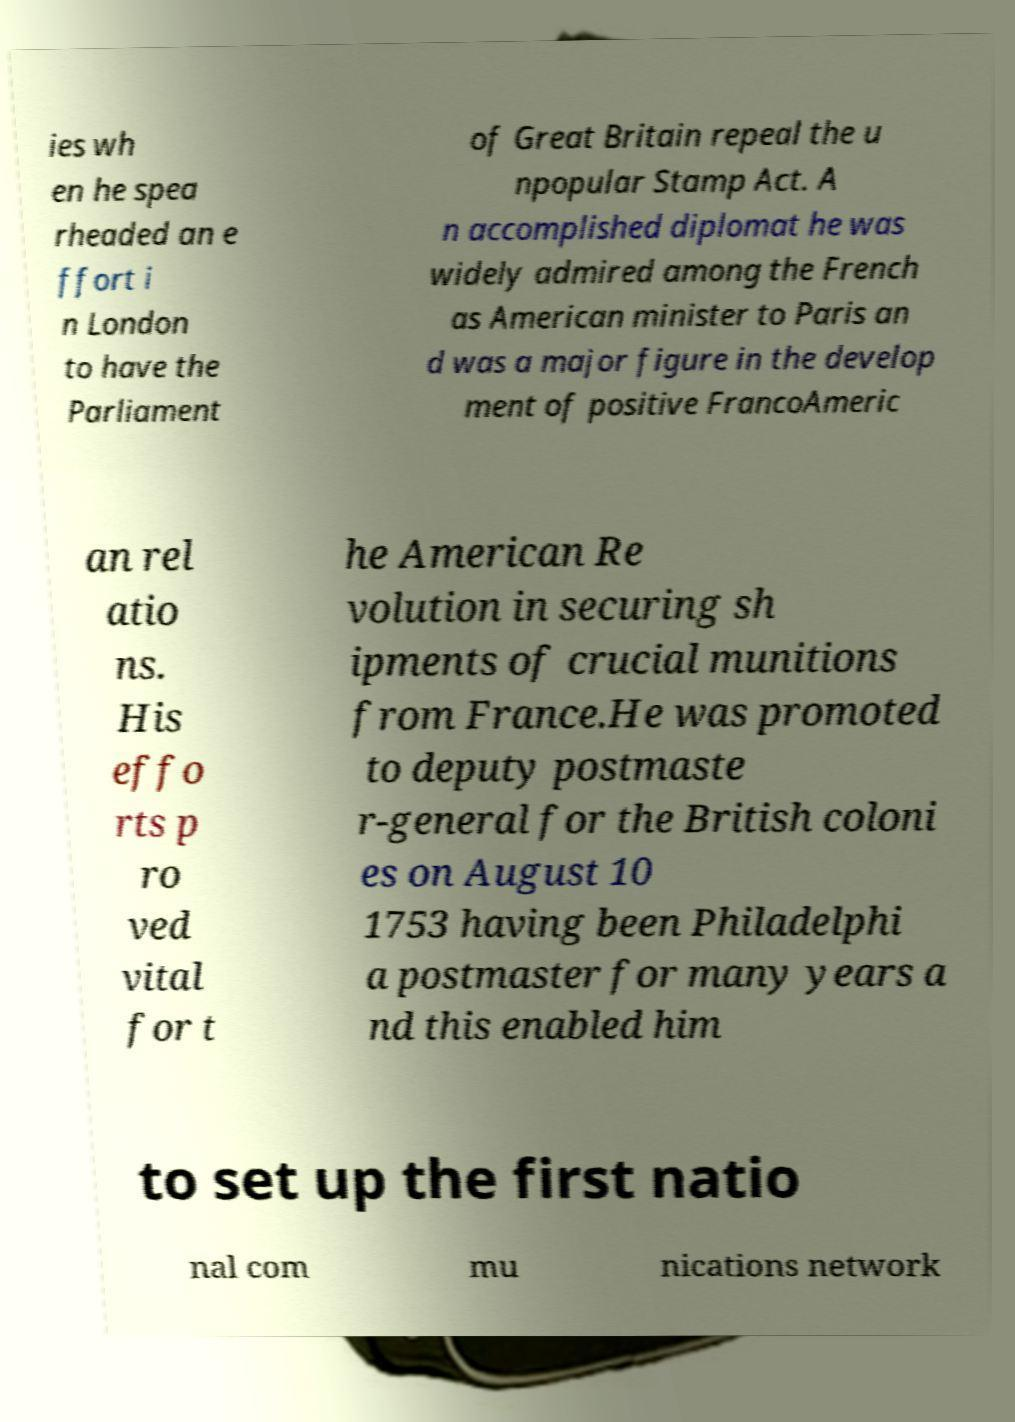I need the written content from this picture converted into text. Can you do that? ies wh en he spea rheaded an e ffort i n London to have the Parliament of Great Britain repeal the u npopular Stamp Act. A n accomplished diplomat he was widely admired among the French as American minister to Paris an d was a major figure in the develop ment of positive FrancoAmeric an rel atio ns. His effo rts p ro ved vital for t he American Re volution in securing sh ipments of crucial munitions from France.He was promoted to deputy postmaste r-general for the British coloni es on August 10 1753 having been Philadelphi a postmaster for many years a nd this enabled him to set up the first natio nal com mu nications network 